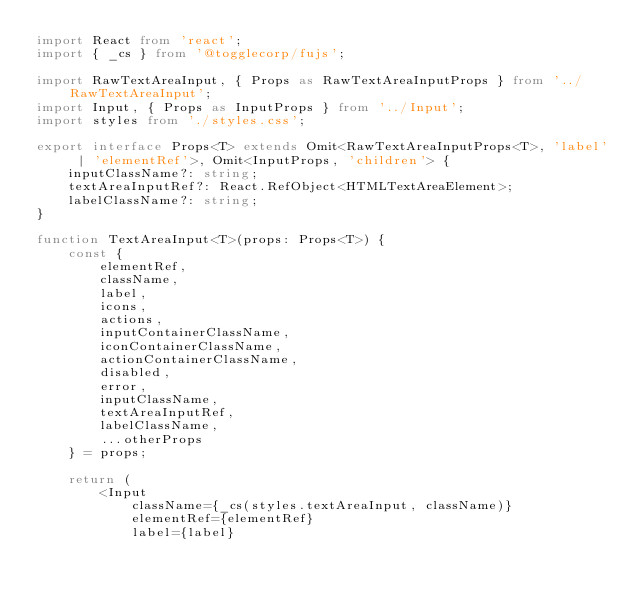Convert code to text. <code><loc_0><loc_0><loc_500><loc_500><_TypeScript_>import React from 'react';
import { _cs } from '@togglecorp/fujs';

import RawTextAreaInput, { Props as RawTextAreaInputProps } from '../RawTextAreaInput';
import Input, { Props as InputProps } from '../Input';
import styles from './styles.css';

export interface Props<T> extends Omit<RawTextAreaInputProps<T>, 'label' | 'elementRef'>, Omit<InputProps, 'children'> {
    inputClassName?: string;
    textAreaInputRef?: React.RefObject<HTMLTextAreaElement>;
    labelClassName?: string;
}

function TextAreaInput<T>(props: Props<T>) {
    const {
        elementRef,
        className,
        label,
        icons,
        actions,
        inputContainerClassName,
        iconContainerClassName,
        actionContainerClassName,
        disabled,
        error,
        inputClassName,
        textAreaInputRef,
        labelClassName,
        ...otherProps
    } = props;

    return (
        <Input
            className={_cs(styles.textAreaInput, className)}
            elementRef={elementRef}
            label={label}</code> 